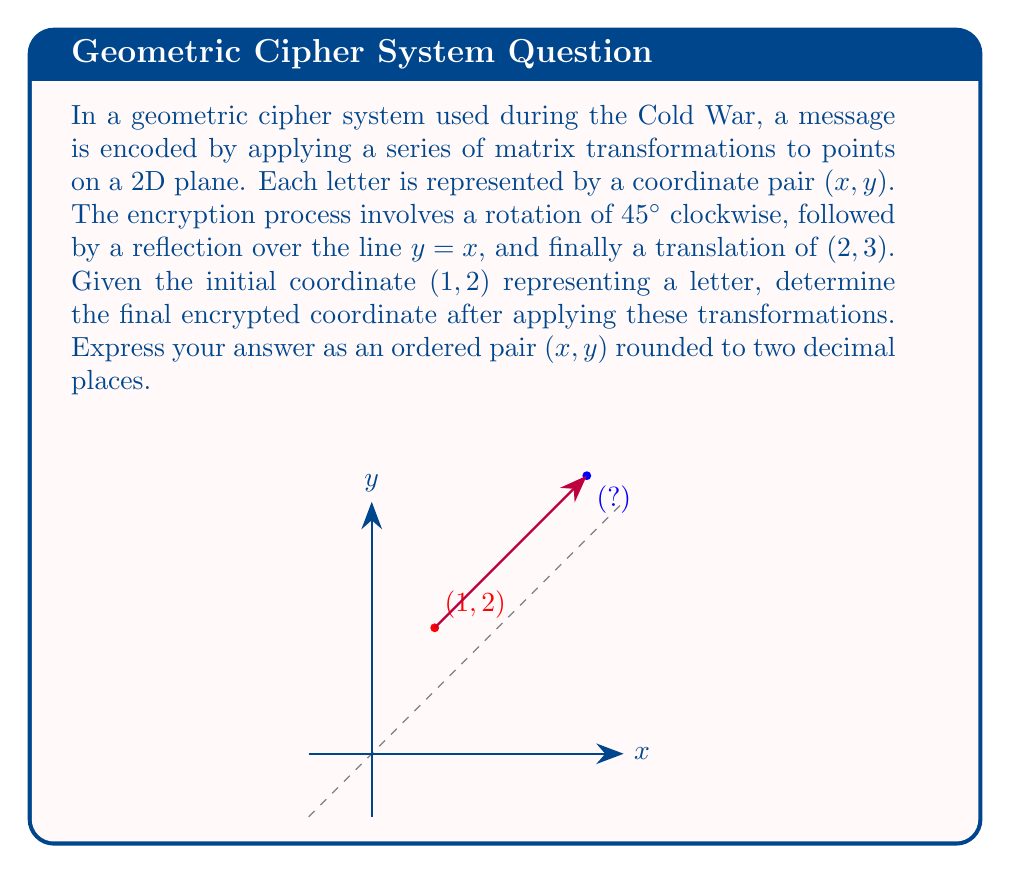Show me your answer to this math problem. Let's break this down step-by-step:

1) First, we need to represent each transformation as a matrix:

   Rotation by 45° clockwise: 
   $$R = \begin{bmatrix} \cos(-45°) & -\sin(-45°) \\ \sin(-45°) & \cos(-45°) \end{bmatrix} = \begin{bmatrix} \frac{\sqrt{2}}{2} & \frac{\sqrt{2}}{2} \\ -\frac{\sqrt{2}}{2} & \frac{\sqrt{2}}{2} \end{bmatrix}$$

   Reflection over y = x:
   $$F = \begin{bmatrix} 0 & 1 \\ 1 & 0 \end{bmatrix}$$

   Translation by (2, 3):
   $$T = \begin{bmatrix} 1 & 0 & 2 \\ 0 & 1 & 3 \\ 0 & 0 & 1 \end{bmatrix}$$

2) We apply these transformations in order. Let's start with the initial point (1, 2):

   $$\begin{bmatrix} 1 \\ 2 \end{bmatrix}$$

3) Apply rotation:

   $$R\begin{bmatrix} 1 \\ 2 \end{bmatrix} = \begin{bmatrix} \frac{\sqrt{2}}{2} & \frac{\sqrt{2}}{2} \\ -\frac{\sqrt{2}}{2} & \frac{\sqrt{2}}{2} \end{bmatrix}\begin{bmatrix} 1 \\ 2 \end{bmatrix} = \begin{bmatrix} \frac{3\sqrt{2}}{2} \\ \frac{\sqrt{2}}{2} \end{bmatrix}$$

4) Apply reflection:

   $$F\begin{bmatrix} \frac{3\sqrt{2}}{2} \\ \frac{\sqrt{2}}{2} \end{bmatrix} = \begin{bmatrix} 0 & 1 \\ 1 & 0 \end{bmatrix}\begin{bmatrix} \frac{3\sqrt{2}}{2} \\ \frac{\sqrt{2}}{2} \end{bmatrix} = \begin{bmatrix} \frac{\sqrt{2}}{2} \\ \frac{3\sqrt{2}}{2} \end{bmatrix}$$

5) Apply translation:

   $$T\begin{bmatrix} \frac{\sqrt{2}}{2} \\ \frac{3\sqrt{2}}{2} \\ 1 \end{bmatrix} = \begin{bmatrix} 1 & 0 & 2 \\ 0 & 1 & 3 \\ 0 & 0 & 1 \end{bmatrix}\begin{bmatrix} \frac{\sqrt{2}}{2} \\ \frac{3\sqrt{2}}{2} \\ 1 \end{bmatrix} = \begin{bmatrix} \frac{\sqrt{2}}{2} + 2 \\ \frac{3\sqrt{2}}{2} + 3 \\ 1 \end{bmatrix}$$

6) The final coordinate is:

   $$\left(\frac{\sqrt{2}}{2} + 2, \frac{3\sqrt{2}}{2} + 3\right)$$

7) Simplifying and rounding to two decimal places:

   $$(2 + 0.71, 3 + 2.12) \approx (2.71, 5.12)$$
Answer: (2.71, 5.12) 